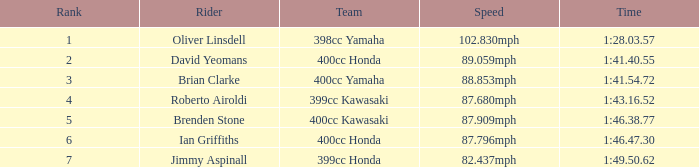What is the standing of the rider who has a time of 1:41.40.55? 2.0. 